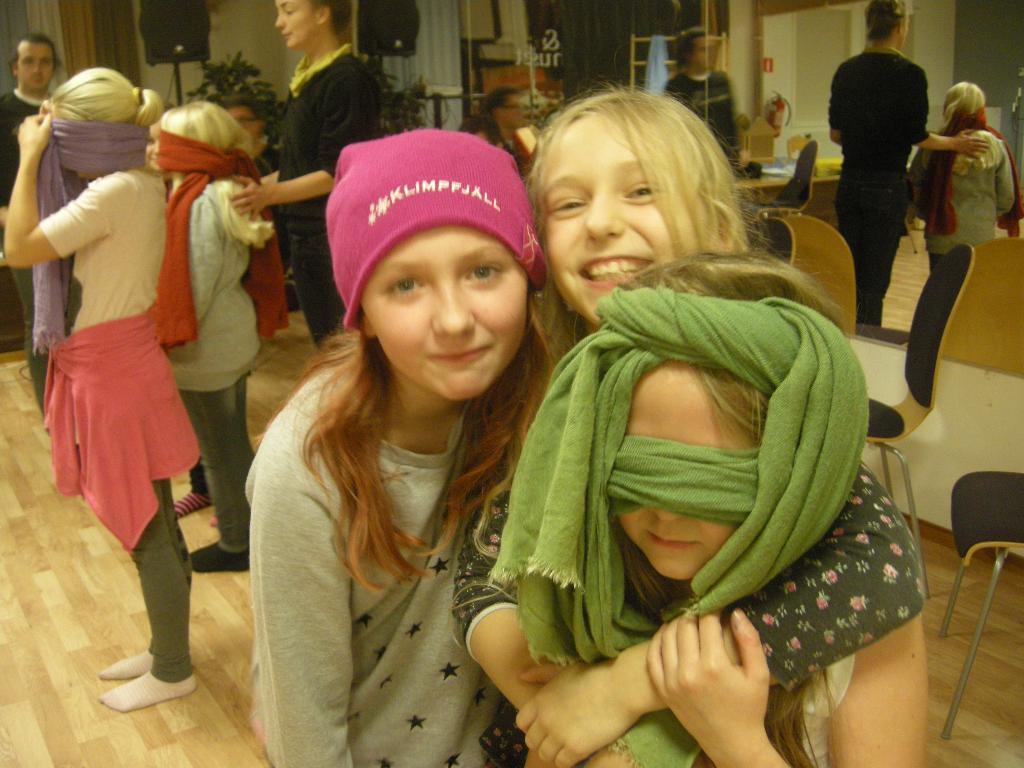Describe this image in one or two sentences. In this image I can see a group of people are standing on the floor and I can see chairs, houseplants, speaker stands, windows, curtains, doors and wall. This image is taken may be in a hall. 